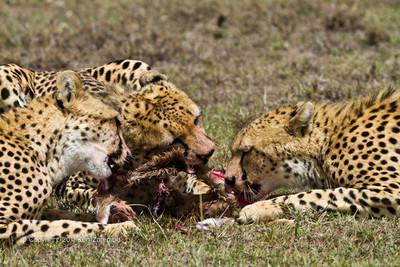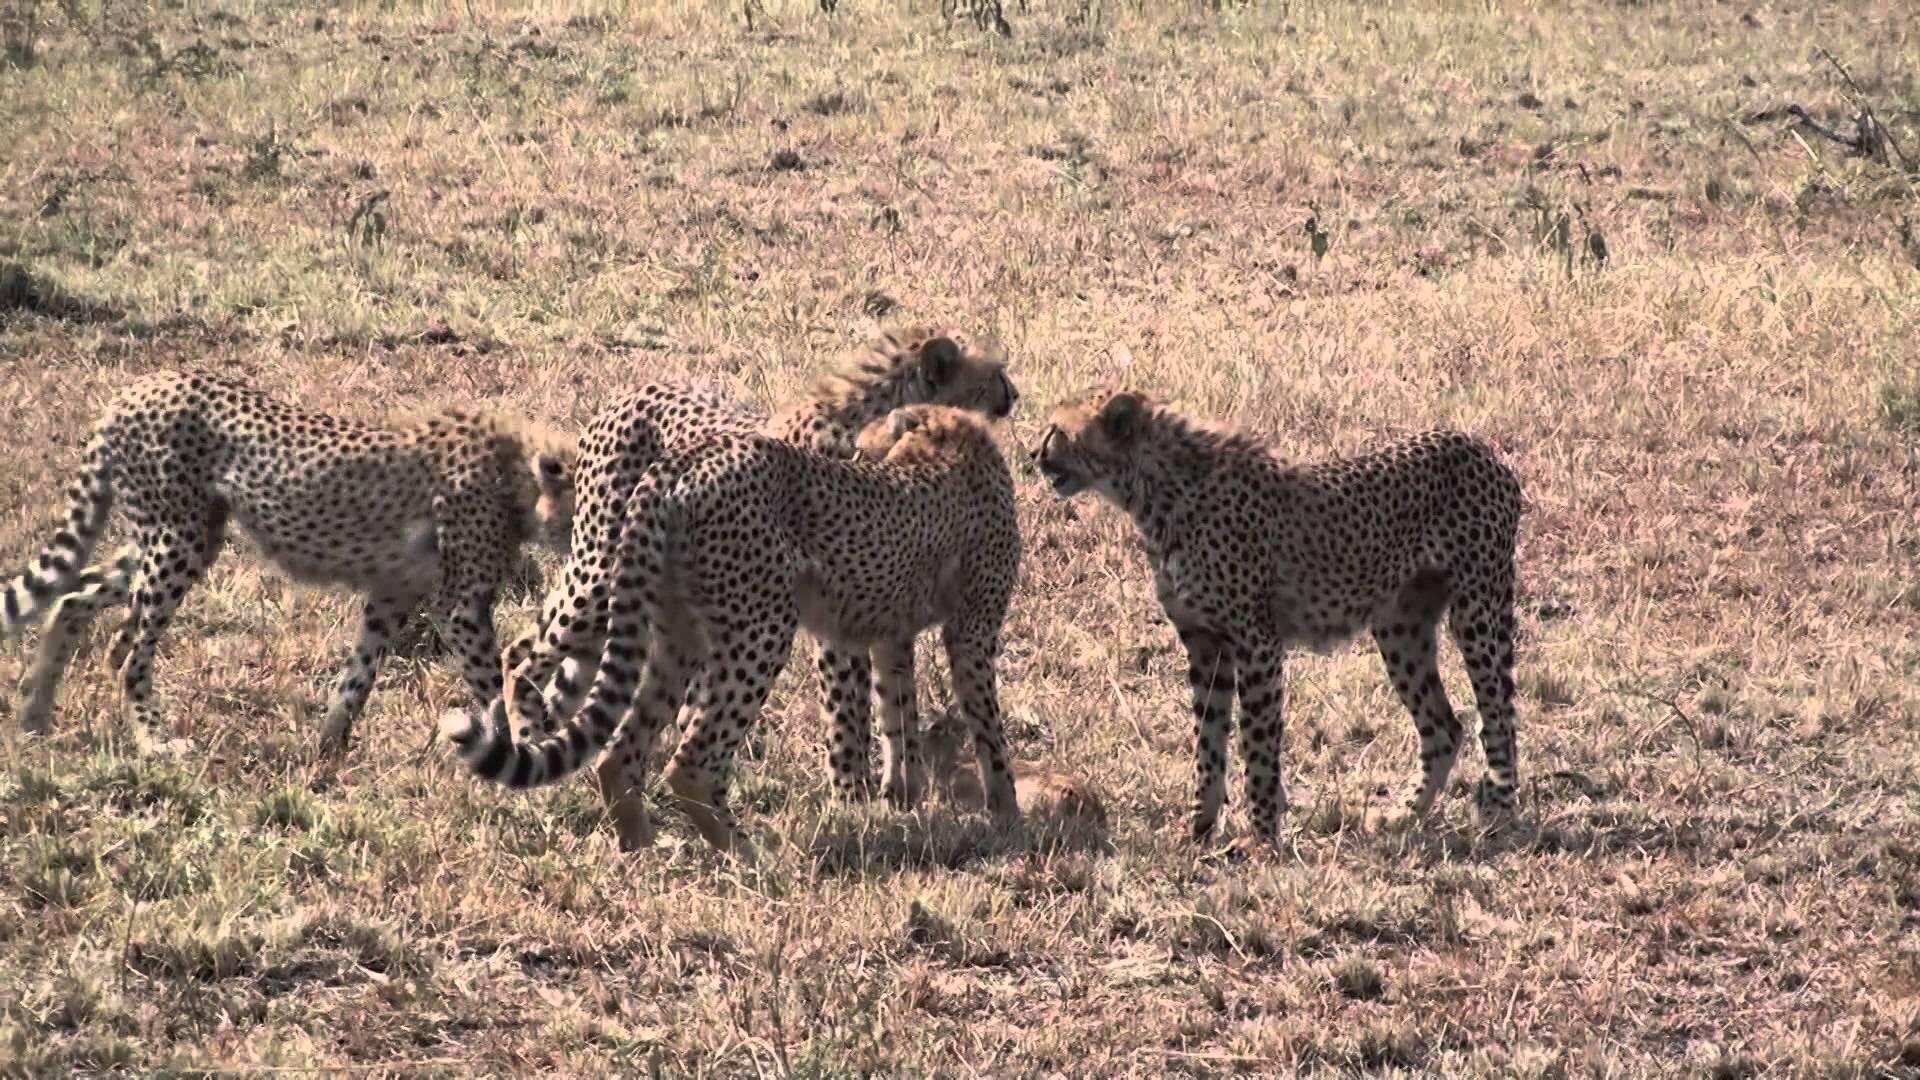The first image is the image on the left, the second image is the image on the right. Analyze the images presented: Is the assertion "One image shows two cheetahs posing non-agressively with a small deerlike animal, and the other shows a cheetah with its prey grasped in its jaw." valid? Answer yes or no. No. The first image is the image on the left, the second image is the image on the right. Assess this claim about the two images: "contains a picture of a cheetah carrying its food". Correct or not? Answer yes or no. No. 